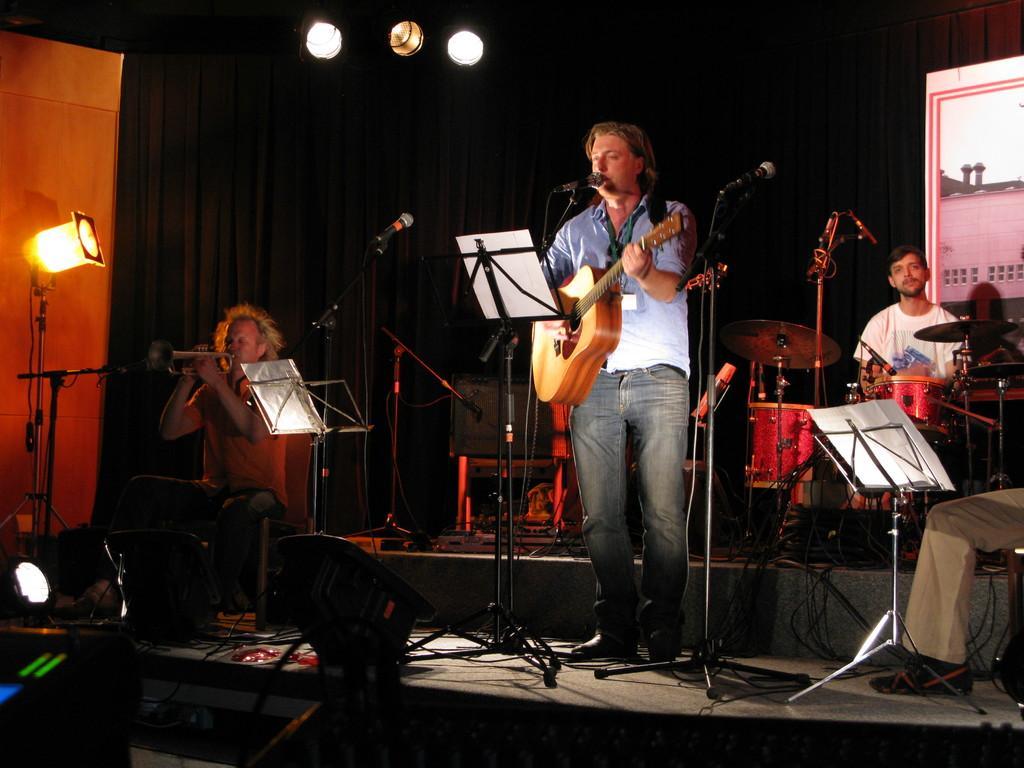Please provide a concise description of this image. In the image we can see four persons in the center we can see one man holding guitar. In front we can see microphones. On the left we can see one man sitting and holding saxophone. On the right we can see person sitting and here on the right we can see human leg. And back we can see curtain and some musical instruments. 